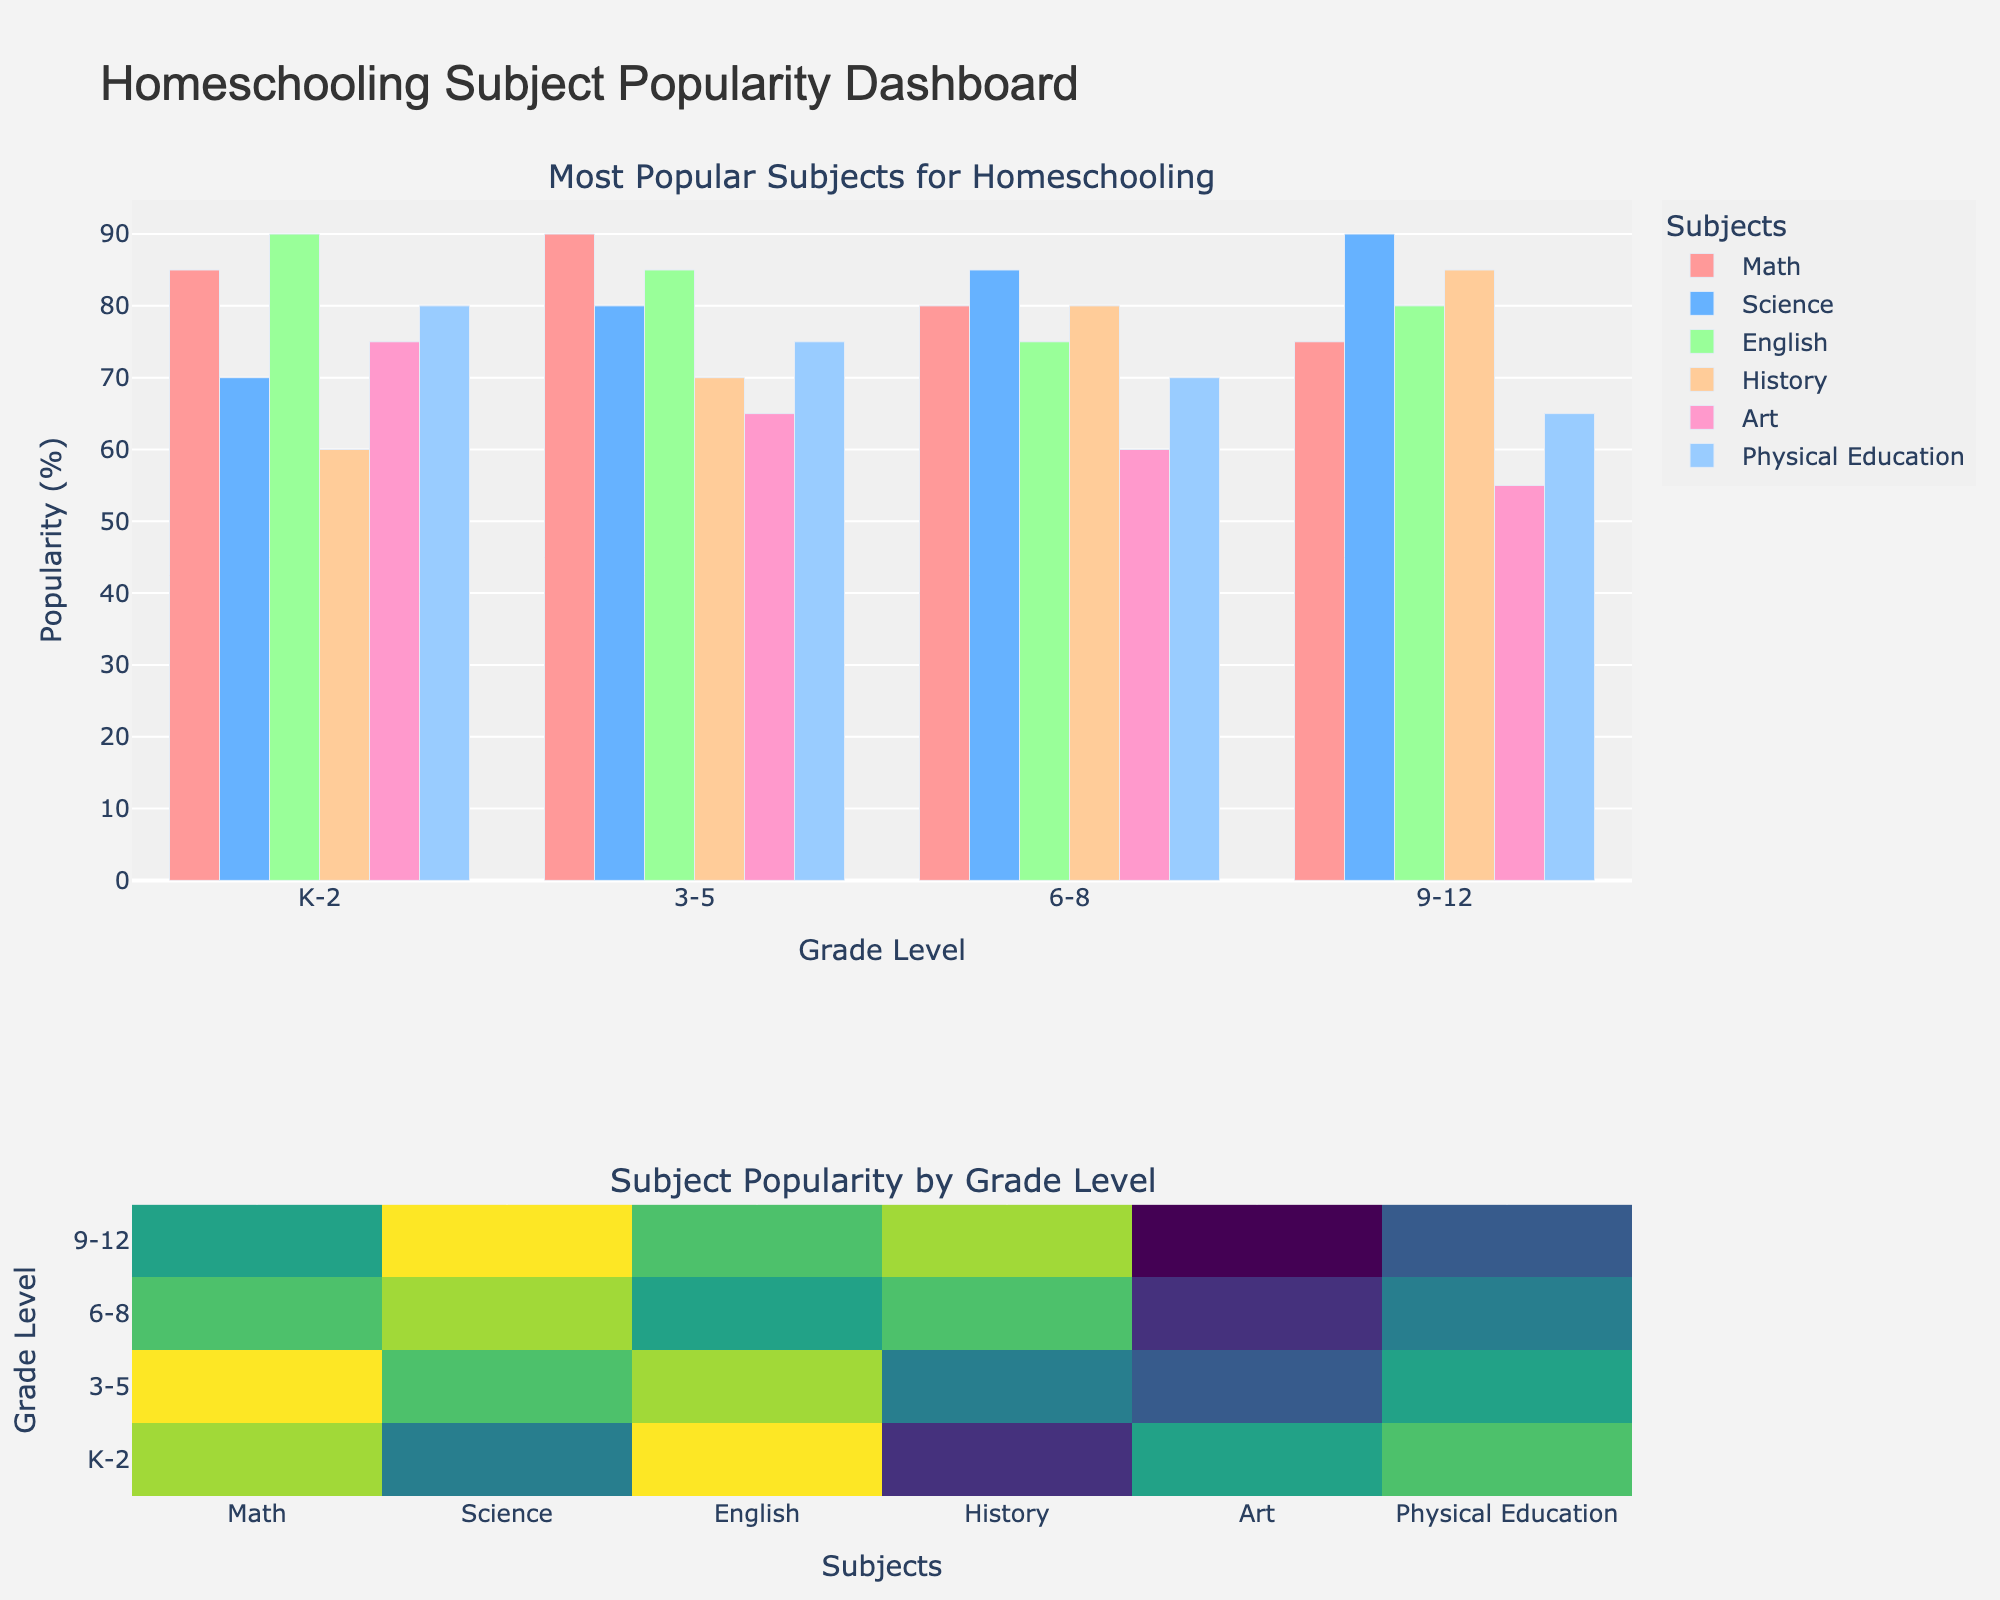What is the most popular subject in grade K-2? By looking at the height of the bars for each subject in grade K-2, we see that the bar representing English is the tallest.
Answer: English Which grade has the highest popularity in Science? By comparing the heights of the Science bars across all grade levels, grade 9-12 has the tallest bar.
Answer: 9-12 What is the combined popularity of Math and Art in grades 6-8? From the figure, the popularity of Math in grades 6-8 is 80, and Art is 60. Summing these values gives us 80 + 60 = 140.
Answer: 140 How does the popularity of Physical Education in grade 3-5 compare to grade 6-8? The bar for Physical Education in grade 3-5 reaches 75, whereas in grade 6-8, it reaches 70. Hence, Physical Education is more popular in grade 3-5.
Answer: More popular in grade 3-5 What is the average popularity of history across all grades? From the figure, History popularity values across grades are 60 (K-2), 70 (3-5), 80 (6-8), and 85 (9-12). The average is calculated as (60 + 70 + 80 + 85) / 4 = 73.75.
Answer: 73.75 Which subject shows a decrease in popularity from grades K-2 to 9-12? By examining the heights of the bars, Math shows a decreasing trend from 85 in K-2 to 75 in 9-12.
Answer: Math Is Art more popular in grades K-2 or grades 9-12? The bar for Art in grade K-2 reaches 75, while in grades 9-12, it reaches 55. Thus, Art is more popular in grades K-2.
Answer: More popular in K-2 What subject has the second highest popularity in grade 6-8? For grade 6-8, the highest bar is Science (85), and the second highest bar is Math (80).
Answer: Math Between English and History, which has greater popularity in grade 3-5? The bar for English in grade 3-5 is 85, while the bar for History is 70. Hence, English is more popular.
Answer: English What is the difference in popularity of Physical Education between grade K-2 and grade 9-12? Physical Education's popularity is 80 in grade K-2 and 65 in grade 9-12. Therefore, the difference is 80 - 65 = 15.
Answer: 15 